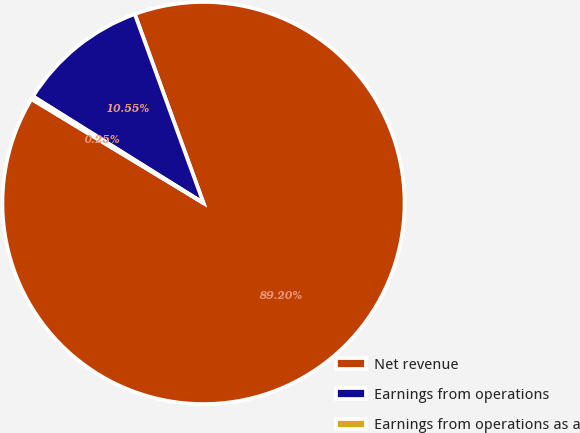Convert chart to OTSL. <chart><loc_0><loc_0><loc_500><loc_500><pie_chart><fcel>Net revenue<fcel>Earnings from operations<fcel>Earnings from operations as a<nl><fcel>89.2%<fcel>10.55%<fcel>0.25%<nl></chart> 